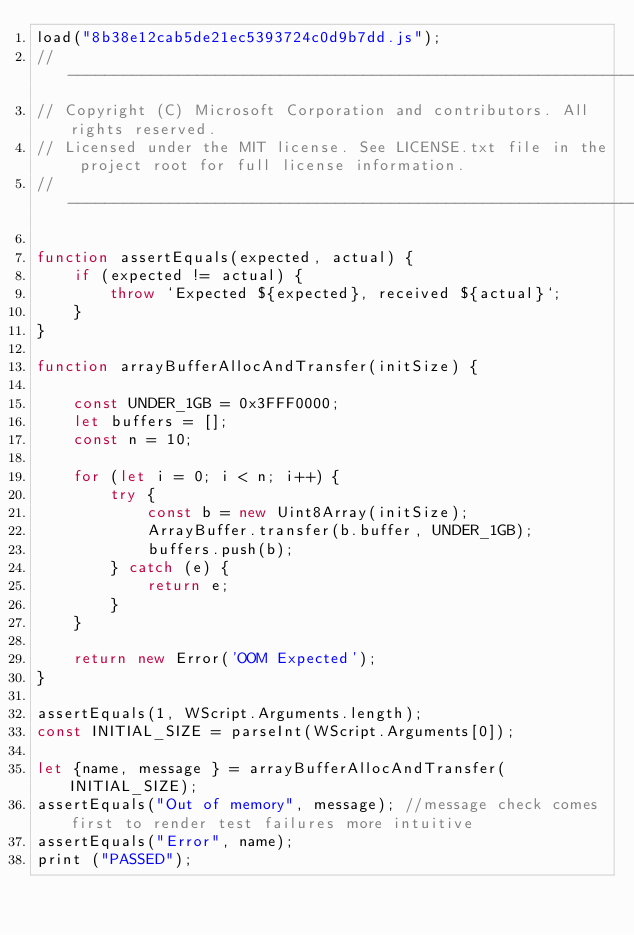<code> <loc_0><loc_0><loc_500><loc_500><_JavaScript_>load("8b38e12cab5de21ec5393724c0d9b7dd.js");
//-------------------------------------------------------------------------------------------------------
// Copyright (C) Microsoft Corporation and contributors. All rights reserved.
// Licensed under the MIT license. See LICENSE.txt file in the project root for full license information.
//-------------------------------------------------------------------------------------------------------

function assertEquals(expected, actual) {
    if (expected != actual) {
        throw `Expected ${expected}, received ${actual}`;
    }
}

function arrayBufferAllocAndTransfer(initSize) {

    const UNDER_1GB = 0x3FFF0000;
    let buffers = [];
    const n = 10;

    for (let i = 0; i < n; i++) {
        try {
            const b = new Uint8Array(initSize);
            ArrayBuffer.transfer(b.buffer, UNDER_1GB);
            buffers.push(b);
        } catch (e) {
            return e;
        }
    }

    return new Error('OOM Expected');
}

assertEquals(1, WScript.Arguments.length);
const INITIAL_SIZE = parseInt(WScript.Arguments[0]);

let {name, message } = arrayBufferAllocAndTransfer(INITIAL_SIZE);
assertEquals("Out of memory", message); //message check comes first to render test failures more intuitive
assertEquals("Error", name);
print ("PASSED");
</code> 